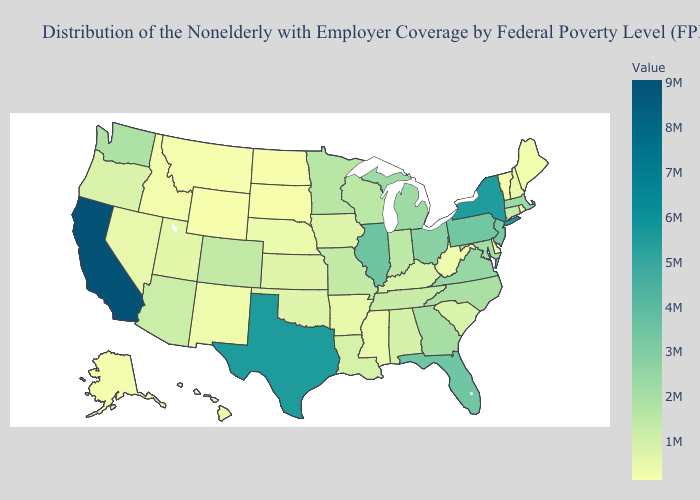Does South Carolina have the highest value in the USA?
Keep it brief. No. Does California have the highest value in the USA?
Give a very brief answer. Yes. Which states hav the highest value in the MidWest?
Keep it brief. Illinois. Among the states that border Ohio , which have the highest value?
Give a very brief answer. Pennsylvania. Does Delaware have the lowest value in the South?
Concise answer only. Yes. 